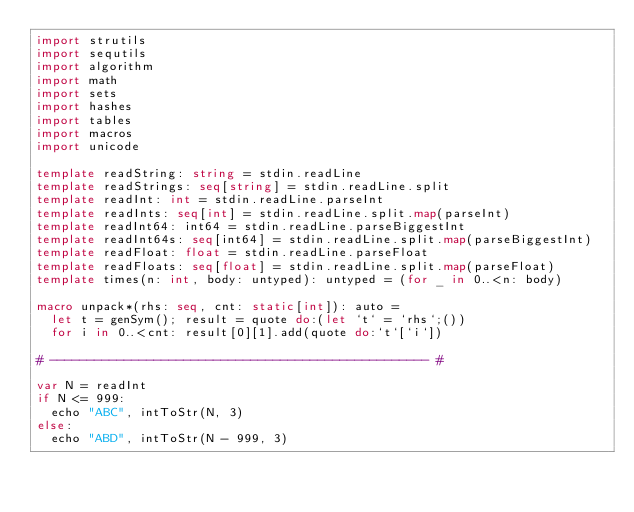<code> <loc_0><loc_0><loc_500><loc_500><_Nim_>import strutils
import sequtils
import algorithm
import math
import sets
import hashes
import tables
import macros
import unicode

template readString: string = stdin.readLine
template readStrings: seq[string] = stdin.readLine.split
template readInt: int = stdin.readLine.parseInt
template readInts: seq[int] = stdin.readLine.split.map(parseInt)
template readInt64: int64 = stdin.readLine.parseBiggestInt
template readInt64s: seq[int64] = stdin.readLine.split.map(parseBiggestInt)
template readFloat: float = stdin.readLine.parseFloat
template readFloats: seq[float] = stdin.readLine.split.map(parseFloat)
template times(n: int, body: untyped): untyped = (for _ in 0..<n: body)

macro unpack*(rhs: seq, cnt: static[int]): auto =
  let t = genSym(); result = quote do:(let `t` = `rhs`;())
  for i in 0..<cnt: result[0][1].add(quote do:`t`[`i`])

# --------------------------------------------------- #

var N = readInt
if N <= 999:
  echo "ABC", intToStr(N, 3)
else:
  echo "ABD", intToStr(N - 999, 3)</code> 